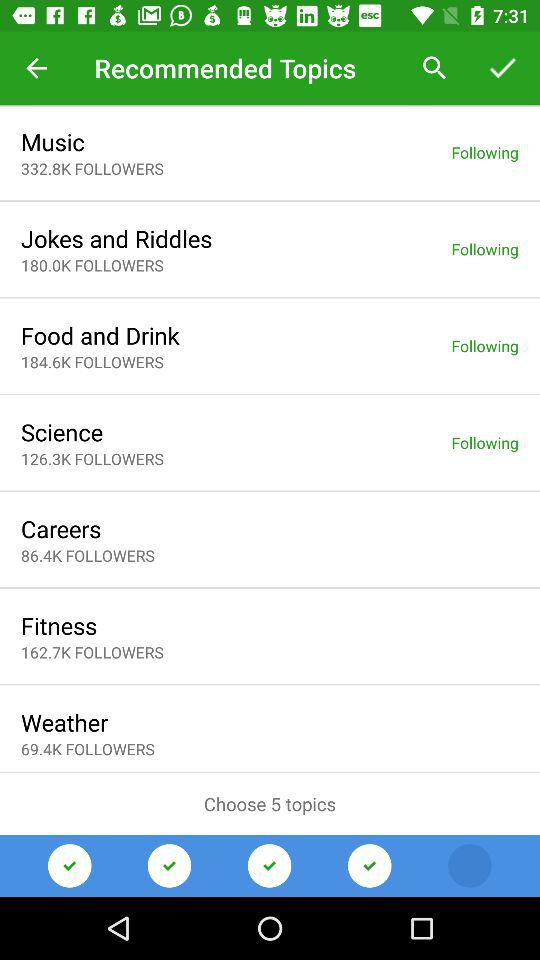What are the recommended topics in the list? The recommended topics are "Music", "Jokes and Riddles", "Food and Drink", "Science", "Careers", "Fitness" and "Weather". 